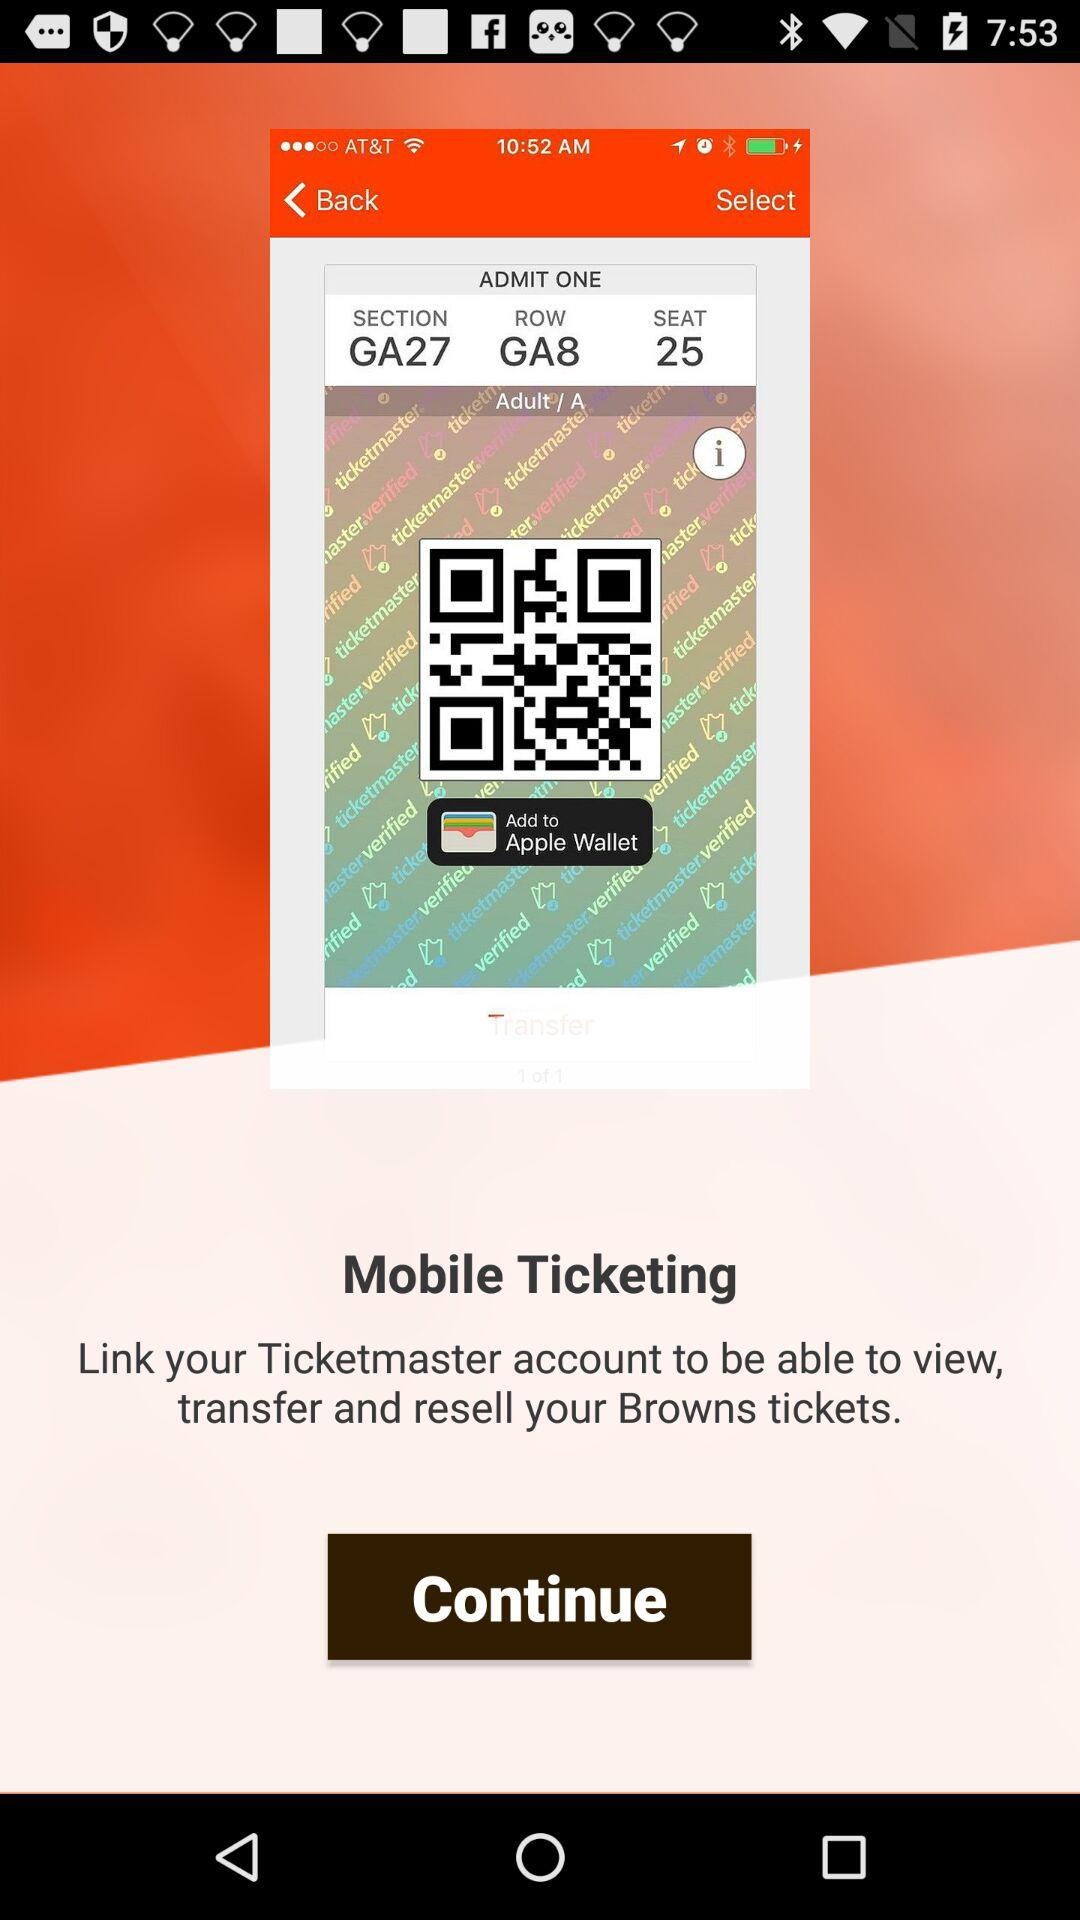What is the name of the application? The names of the applications are "Mobile Ticketing" and "Ticketmaster". 